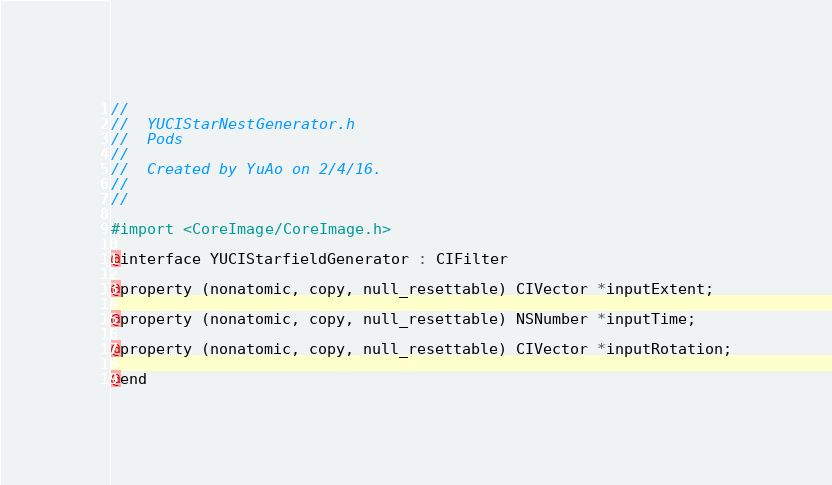Convert code to text. <code><loc_0><loc_0><loc_500><loc_500><_C_>//
//  YUCIStarNestGenerator.h
//  Pods
//
//  Created by YuAo on 2/4/16.
//
//

#import <CoreImage/CoreImage.h>

@interface YUCIStarfieldGenerator : CIFilter

@property (nonatomic, copy, null_resettable) CIVector *inputExtent;

@property (nonatomic, copy, null_resettable) NSNumber *inputTime;

@property (nonatomic, copy, null_resettable) CIVector *inputRotation;

@end
</code> 